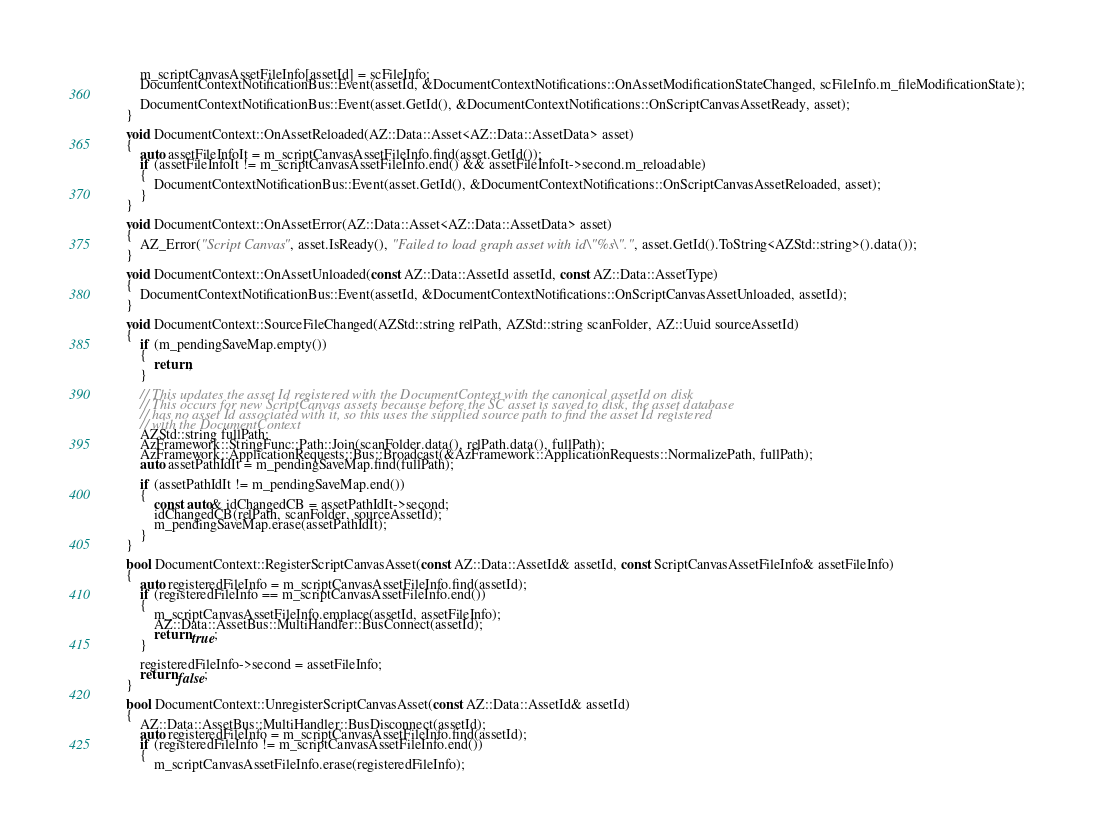<code> <loc_0><loc_0><loc_500><loc_500><_C++_>        m_scriptCanvasAssetFileInfo[assetId] = scFileInfo;
        DocumentContextNotificationBus::Event(assetId, &DocumentContextNotifications::OnAssetModificationStateChanged, scFileInfo.m_fileModificationState);

        DocumentContextNotificationBus::Event(asset.GetId(), &DocumentContextNotifications::OnScriptCanvasAssetReady, asset);
    }

    void DocumentContext::OnAssetReloaded(AZ::Data::Asset<AZ::Data::AssetData> asset)
    {
        auto assetFileInfoIt = m_scriptCanvasAssetFileInfo.find(asset.GetId());
        if (assetFileInfoIt != m_scriptCanvasAssetFileInfo.end() && assetFileInfoIt->second.m_reloadable)
        {
            DocumentContextNotificationBus::Event(asset.GetId(), &DocumentContextNotifications::OnScriptCanvasAssetReloaded, asset);
        }
    }

    void DocumentContext::OnAssetError(AZ::Data::Asset<AZ::Data::AssetData> asset)
    {
        AZ_Error("Script Canvas", asset.IsReady(), "Failed to load graph asset with id \"%s\".", asset.GetId().ToString<AZStd::string>().data());
    }

    void DocumentContext::OnAssetUnloaded(const AZ::Data::AssetId assetId, const AZ::Data::AssetType)
    {
        DocumentContextNotificationBus::Event(assetId, &DocumentContextNotifications::OnScriptCanvasAssetUnloaded, assetId);
    }

    void DocumentContext::SourceFileChanged(AZStd::string relPath, AZStd::string scanFolder, AZ::Uuid sourceAssetId)
    {
        if (m_pendingSaveMap.empty())
        {
            return;
        }

        // This updates the asset Id registered with the DocumentContext with the canonical assetId on disk
        // This occurs for new ScriptCanvas assets because before the SC asset is saved to disk, the asset database
        // has no asset Id associated with it, so this uses the supplied source path to find the asset Id registered 
        // with the DocumentContext
        AZStd::string fullPath;
        AzFramework::StringFunc::Path::Join(scanFolder.data(), relPath.data(), fullPath);
        AzFramework::ApplicationRequests::Bus::Broadcast(&AzFramework::ApplicationRequests::NormalizePath, fullPath);
        auto assetPathIdIt = m_pendingSaveMap.find(fullPath);

        if (assetPathIdIt != m_pendingSaveMap.end())
        {
            const auto& idChangedCB = assetPathIdIt->second;
            idChangedCB(relPath, scanFolder, sourceAssetId);
            m_pendingSaveMap.erase(assetPathIdIt);
        }
    }

    bool DocumentContext::RegisterScriptCanvasAsset(const AZ::Data::AssetId& assetId, const ScriptCanvasAssetFileInfo& assetFileInfo)
    {
        auto registeredFileInfo = m_scriptCanvasAssetFileInfo.find(assetId);
        if (registeredFileInfo == m_scriptCanvasAssetFileInfo.end())
        {
            m_scriptCanvasAssetFileInfo.emplace(assetId, assetFileInfo);
            AZ::Data::AssetBus::MultiHandler::BusConnect(assetId);
            return true;
        }

        registeredFileInfo->second = assetFileInfo;
        return false;
    }

    bool DocumentContext::UnregisterScriptCanvasAsset(const AZ::Data::AssetId& assetId)
    {
        AZ::Data::AssetBus::MultiHandler::BusDisconnect(assetId);
        auto registeredFileInfo = m_scriptCanvasAssetFileInfo.find(assetId);
        if (registeredFileInfo != m_scriptCanvasAssetFileInfo.end())
        {
            m_scriptCanvasAssetFileInfo.erase(registeredFileInfo);</code> 